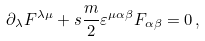Convert formula to latex. <formula><loc_0><loc_0><loc_500><loc_500>\partial _ { \lambda } F ^ { \lambda \mu } + s \frac { m } { 2 } \varepsilon ^ { \mu \alpha \beta } F _ { \alpha \beta } = 0 \, ,</formula> 